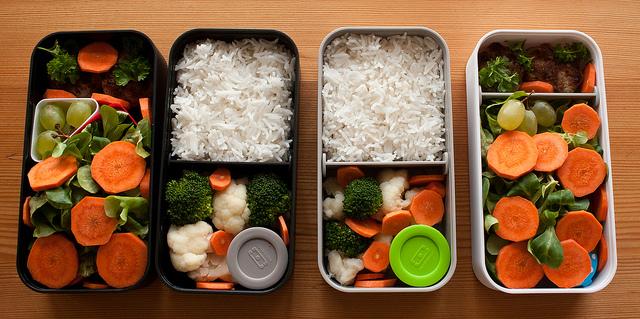What fruits are in these bento boxes?
Quick response, please. Grapes. What is the orange food?
Write a very short answer. Carrots. What shape are the containers?
Concise answer only. Rectangle. 